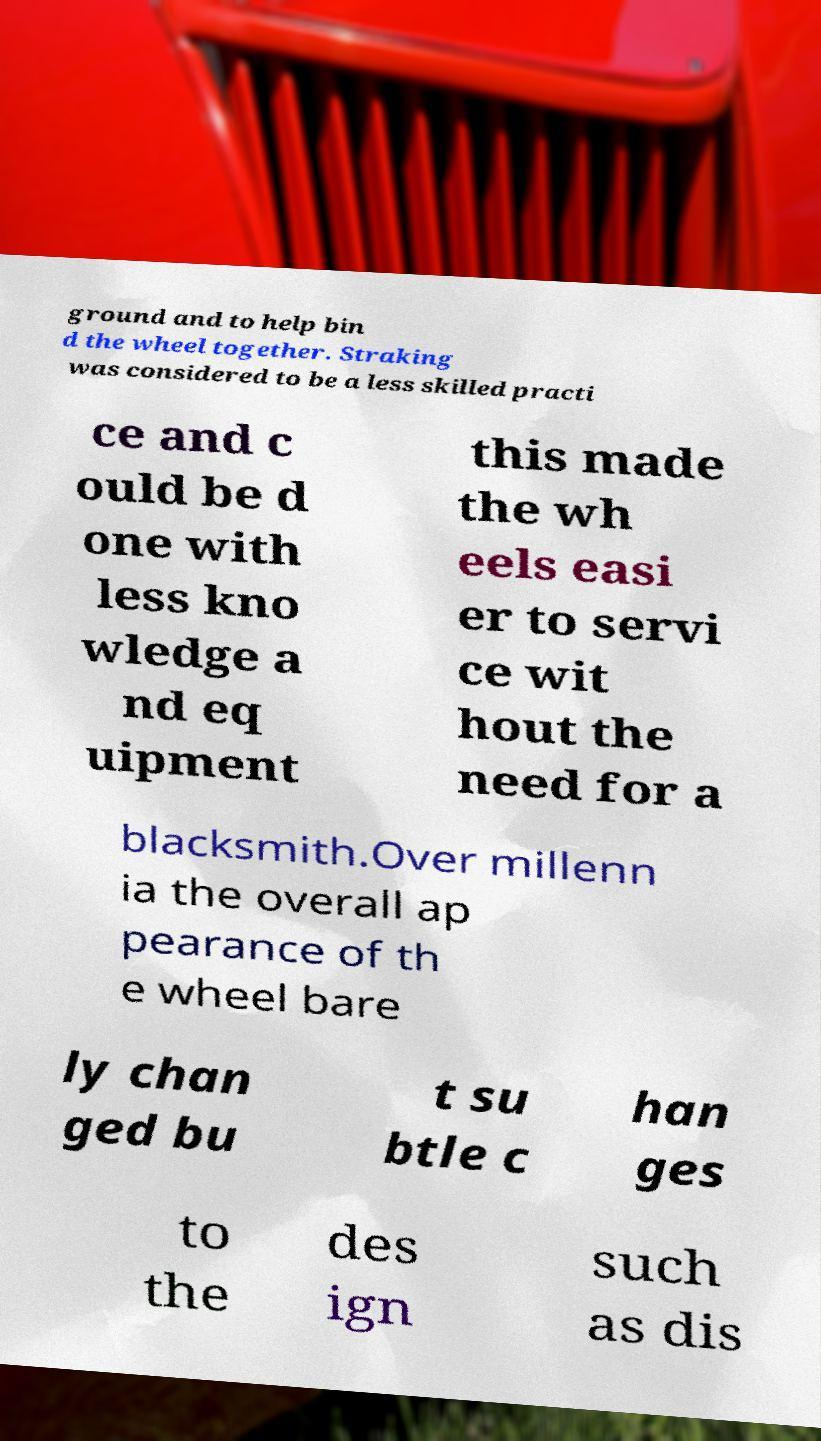Could you assist in decoding the text presented in this image and type it out clearly? ground and to help bin d the wheel together. Straking was considered to be a less skilled practi ce and c ould be d one with less kno wledge a nd eq uipment this made the wh eels easi er to servi ce wit hout the need for a blacksmith.Over millenn ia the overall ap pearance of th e wheel bare ly chan ged bu t su btle c han ges to the des ign such as dis 